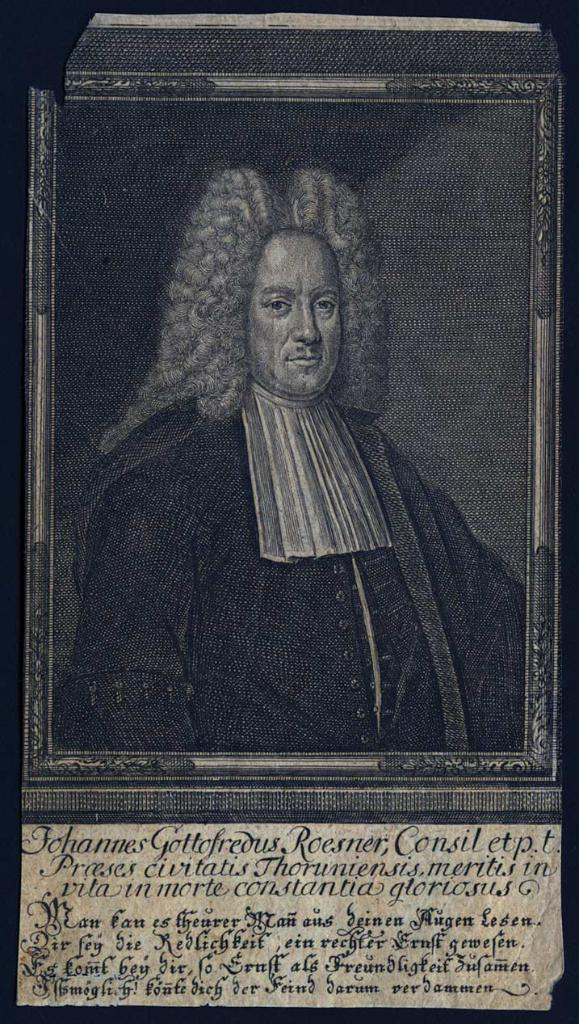What type of image is being described? The image is a poster. What is depicted on the poster? There is a human picture on the poster. Is there any text on the poster? Yes, there is text at the bottom of the poster. What color are the borders of the poster? The borders of the poster are black. Where is the stove located in the image? There is no stove present in the image; it is a poster with a human picture and text. 